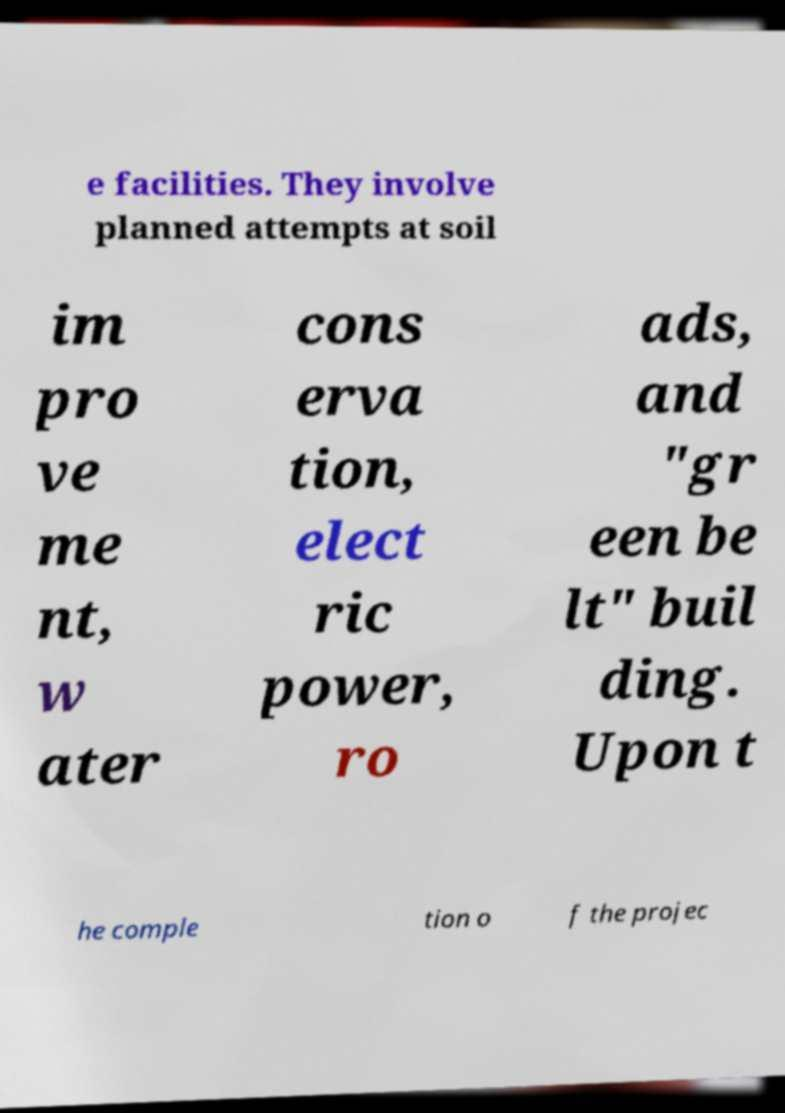For documentation purposes, I need the text within this image transcribed. Could you provide that? e facilities. They involve planned attempts at soil im pro ve me nt, w ater cons erva tion, elect ric power, ro ads, and "gr een be lt" buil ding. Upon t he comple tion o f the projec 